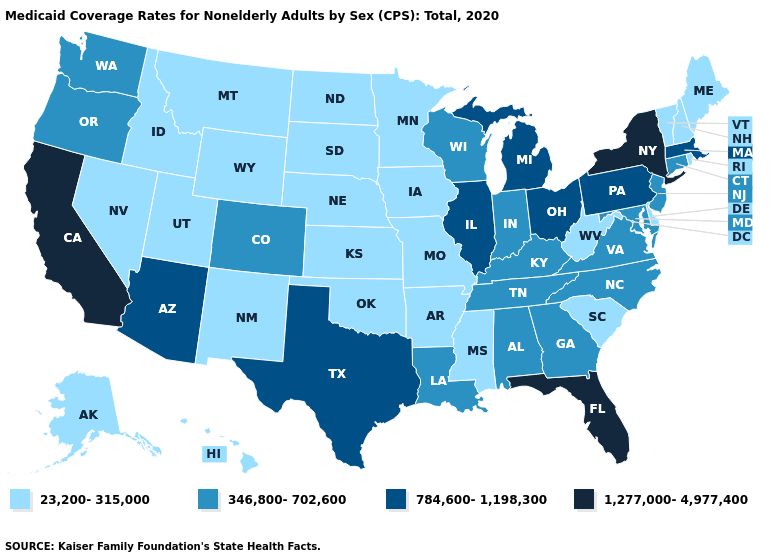Among the states that border Illinois , which have the lowest value?
Keep it brief. Iowa, Missouri. Does Alabama have the lowest value in the USA?
Answer briefly. No. Which states have the lowest value in the USA?
Quick response, please. Alaska, Arkansas, Delaware, Hawaii, Idaho, Iowa, Kansas, Maine, Minnesota, Mississippi, Missouri, Montana, Nebraska, Nevada, New Hampshire, New Mexico, North Dakota, Oklahoma, Rhode Island, South Carolina, South Dakota, Utah, Vermont, West Virginia, Wyoming. What is the value of Florida?
Keep it brief. 1,277,000-4,977,400. Does Colorado have the lowest value in the USA?
Short answer required. No. What is the lowest value in the MidWest?
Write a very short answer. 23,200-315,000. Name the states that have a value in the range 1,277,000-4,977,400?
Short answer required. California, Florida, New York. Name the states that have a value in the range 23,200-315,000?
Be succinct. Alaska, Arkansas, Delaware, Hawaii, Idaho, Iowa, Kansas, Maine, Minnesota, Mississippi, Missouri, Montana, Nebraska, Nevada, New Hampshire, New Mexico, North Dakota, Oklahoma, Rhode Island, South Carolina, South Dakota, Utah, Vermont, West Virginia, Wyoming. Among the states that border Minnesota , does South Dakota have the highest value?
Quick response, please. No. What is the lowest value in states that border Nevada?
Answer briefly. 23,200-315,000. What is the value of Texas?
Give a very brief answer. 784,600-1,198,300. Does the map have missing data?
Quick response, please. No. What is the highest value in the USA?
Keep it brief. 1,277,000-4,977,400. Which states have the lowest value in the Northeast?
Short answer required. Maine, New Hampshire, Rhode Island, Vermont. Name the states that have a value in the range 1,277,000-4,977,400?
Answer briefly. California, Florida, New York. 